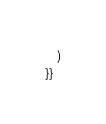<code> <loc_0><loc_0><loc_500><loc_500><_SQL_>    )
}}</code> 